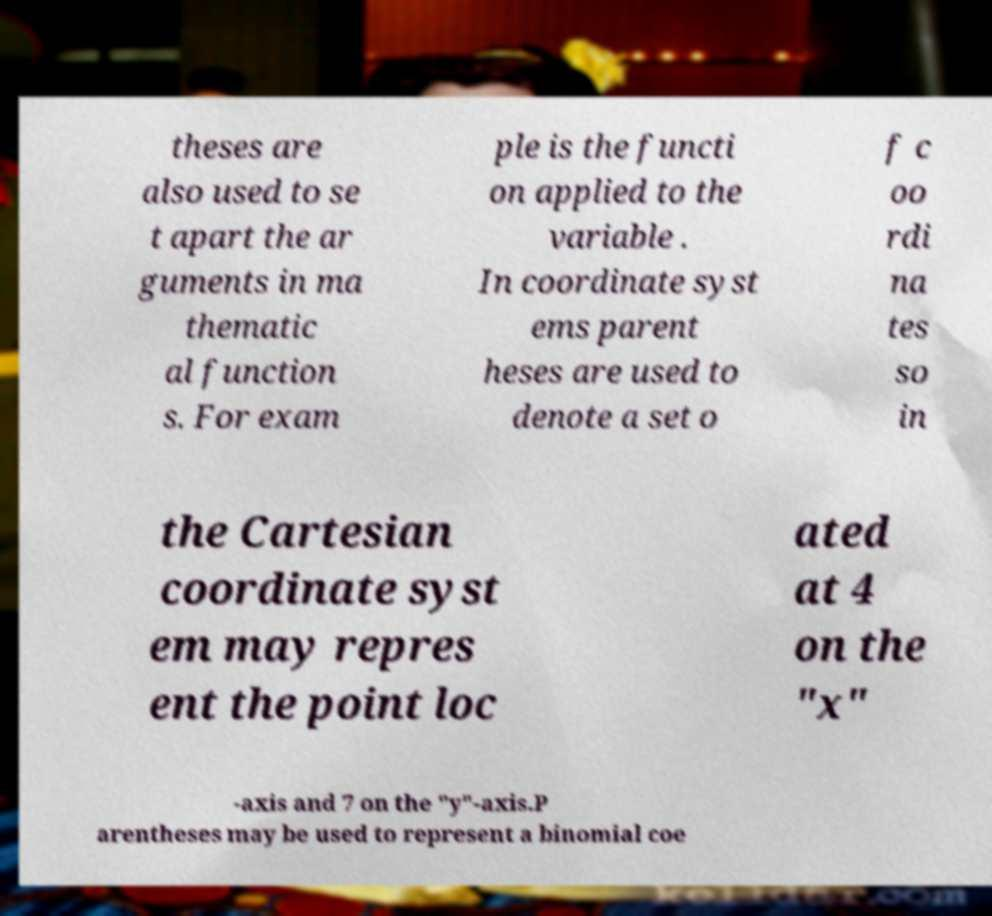Please read and relay the text visible in this image. What does it say? theses are also used to se t apart the ar guments in ma thematic al function s. For exam ple is the functi on applied to the variable . In coordinate syst ems parent heses are used to denote a set o f c oo rdi na tes so in the Cartesian coordinate syst em may repres ent the point loc ated at 4 on the "x" -axis and 7 on the "y"-axis.P arentheses may be used to represent a binomial coe 